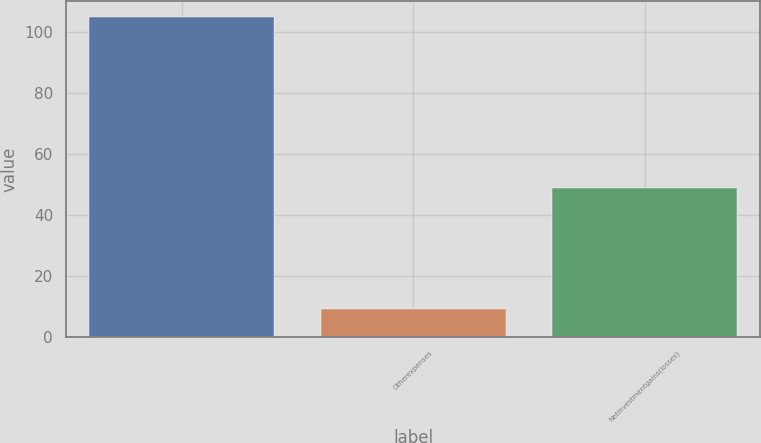Convert chart to OTSL. <chart><loc_0><loc_0><loc_500><loc_500><bar_chart><ecel><fcel>Otherexpenses<fcel>Netinvestmentgains(losses)<nl><fcel>105<fcel>9<fcel>49<nl></chart> 